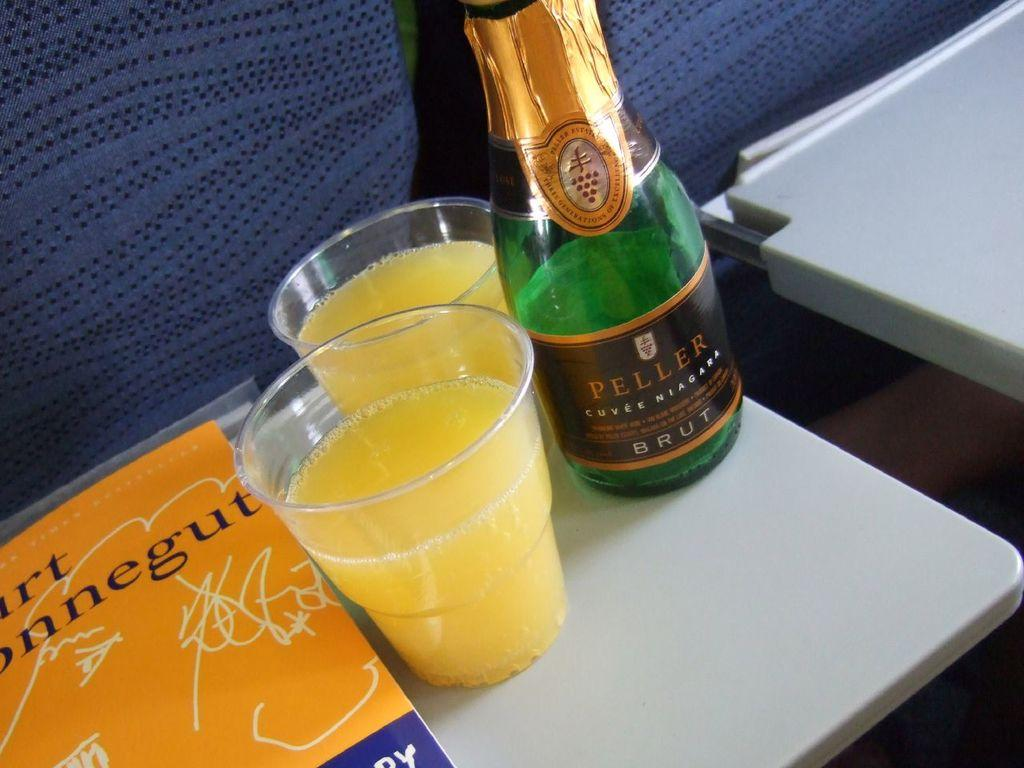What type of bottle is visible in the image? There is a green color glass bottle in the image. How many cups are present in the image? There are two cups in the image. What object can be seen on a table in the image? There is a book on a table in the image. What type of scarf is draped over the book in the image? There is no scarf present in the image; it only features a green color glass bottle, two cups, and a book on a table. Can you tell me how many languages are spoken by the volcano in the image? There is no volcano present in the image, and therefore it cannot speak any languages. 